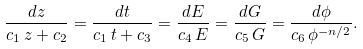Convert formula to latex. <formula><loc_0><loc_0><loc_500><loc_500>\frac { d z } { c _ { 1 } \, z + c _ { 2 } } = \frac { d t } { c _ { 1 } \, t + c _ { 3 } } = \frac { d E } { c _ { 4 } \, E } = \frac { d G } { c _ { 5 } \, G } = \frac { d \phi } { c _ { 6 } \, \phi ^ { - n / 2 } } .</formula> 